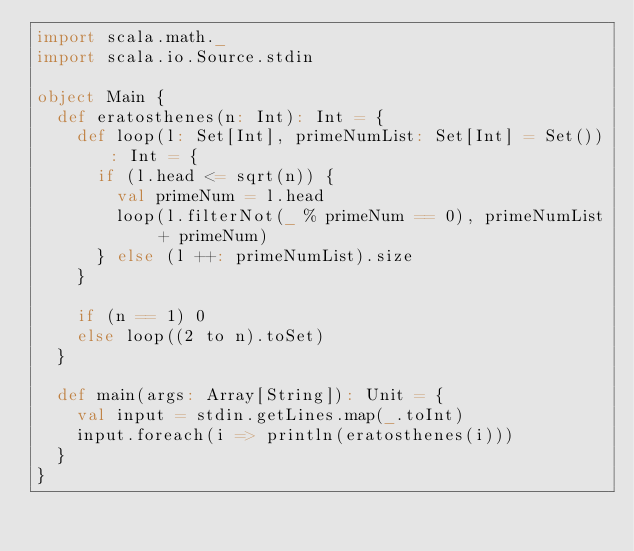<code> <loc_0><loc_0><loc_500><loc_500><_Scala_>import scala.math._
import scala.io.Source.stdin

object Main {
  def eratosthenes(n: Int): Int = {
    def loop(l: Set[Int], primeNumList: Set[Int] = Set()): Int = {
      if (l.head <= sqrt(n)) {
        val primeNum = l.head
        loop(l.filterNot(_ % primeNum == 0), primeNumList + primeNum)
      } else (l ++: primeNumList).size
    }

    if (n == 1) 0
    else loop((2 to n).toSet)
  }

  def main(args: Array[String]): Unit = {
    val input = stdin.getLines.map(_.toInt)
    input.foreach(i => println(eratosthenes(i)))
  }
}</code> 